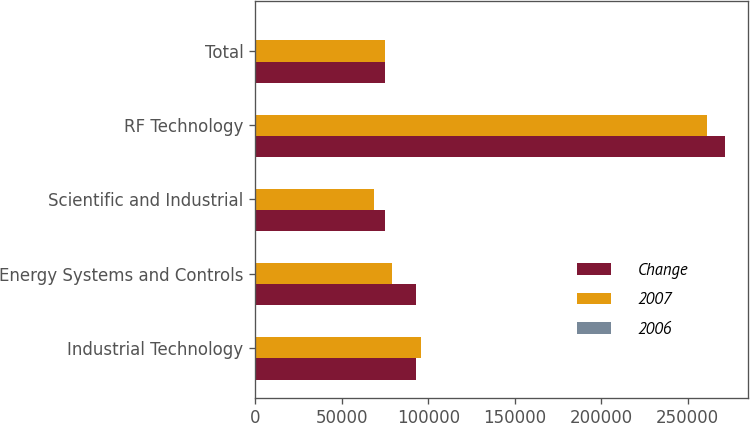Convert chart to OTSL. <chart><loc_0><loc_0><loc_500><loc_500><stacked_bar_chart><ecel><fcel>Industrial Technology<fcel>Energy Systems and Controls<fcel>Scientific and Industrial<fcel>RF Technology<fcel>Total<nl><fcel>Change<fcel>93076<fcel>93102<fcel>74834<fcel>271305<fcel>74834<nl><fcel>2007<fcel>95539<fcel>79217<fcel>68600<fcel>261243<fcel>74834<nl><fcel>2006<fcel>2.6<fcel>17.5<fcel>9.1<fcel>3.9<fcel>5.5<nl></chart> 